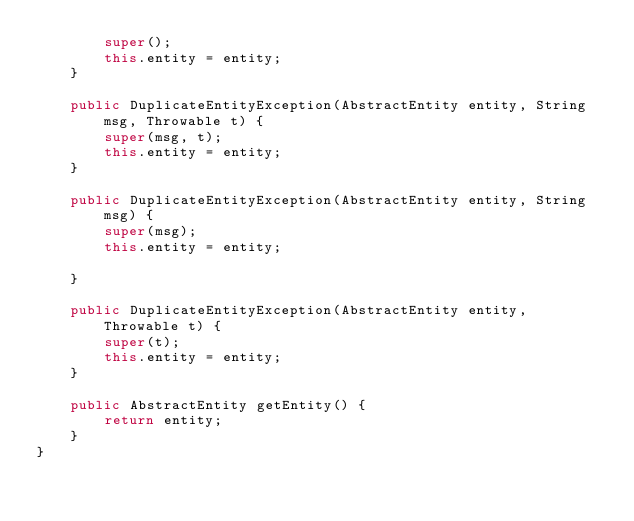<code> <loc_0><loc_0><loc_500><loc_500><_Java_>		super();
		this.entity = entity;
	}

	public DuplicateEntityException(AbstractEntity entity, String msg, Throwable t) {
		super(msg, t);
		this.entity = entity;
	}

	public DuplicateEntityException(AbstractEntity entity, String msg) {
		super(msg);
		this.entity = entity;
		
	}

	public DuplicateEntityException(AbstractEntity entity, Throwable t) {
		super(t);
		this.entity = entity;
	}

	public AbstractEntity getEntity() {
		return entity;
	}
}
</code> 